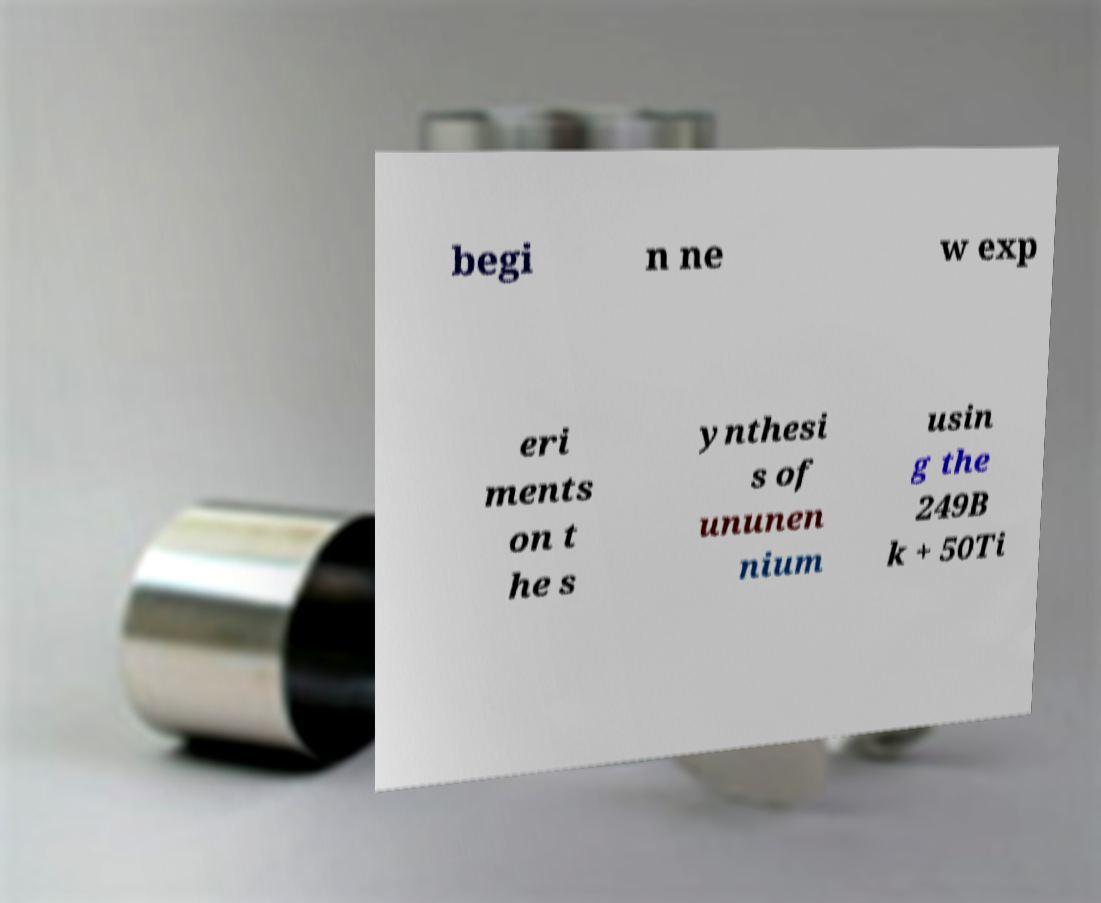Please identify and transcribe the text found in this image. begi n ne w exp eri ments on t he s ynthesi s of ununen nium usin g the 249B k + 50Ti 